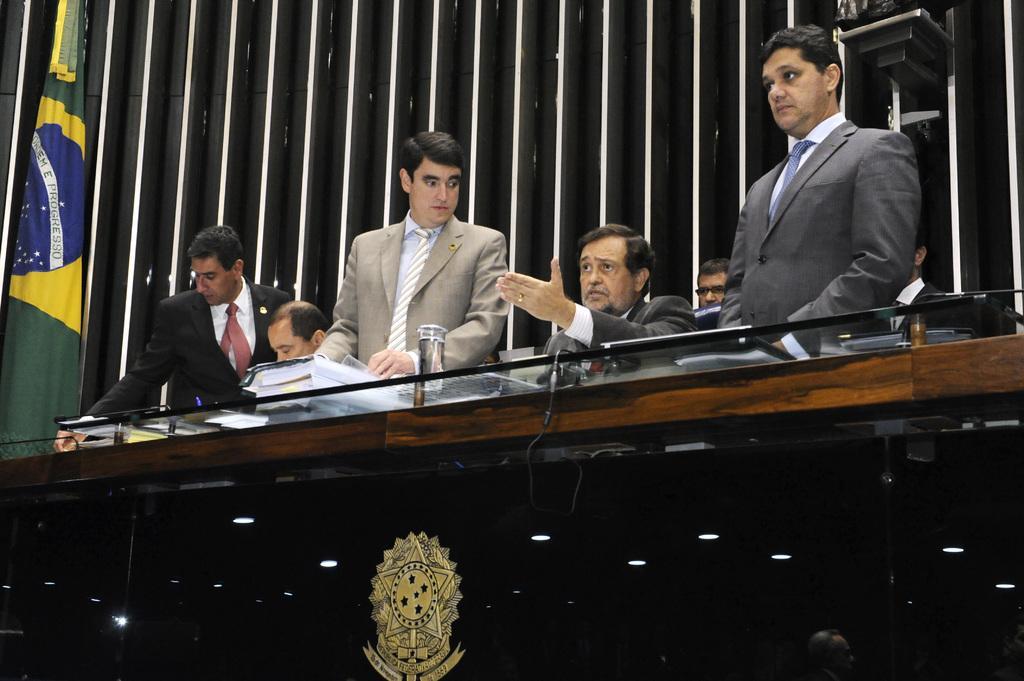Describe this image in one or two sentences. In this image we can see few people sitting. We can see people standing. There are few objects on the glass. There is a flag at the left side of the image. There are few lights in the image. There is a logo at the bottom of the image. 